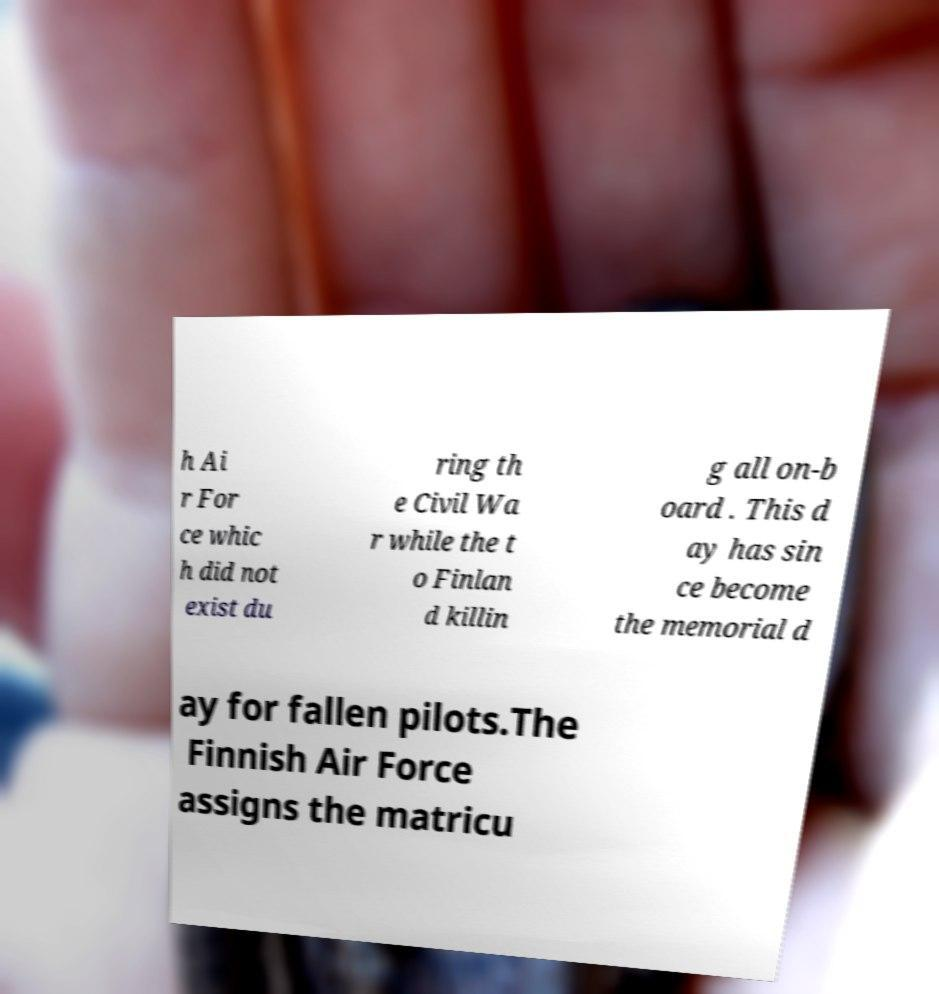For documentation purposes, I need the text within this image transcribed. Could you provide that? h Ai r For ce whic h did not exist du ring th e Civil Wa r while the t o Finlan d killin g all on-b oard . This d ay has sin ce become the memorial d ay for fallen pilots.The Finnish Air Force assigns the matricu 